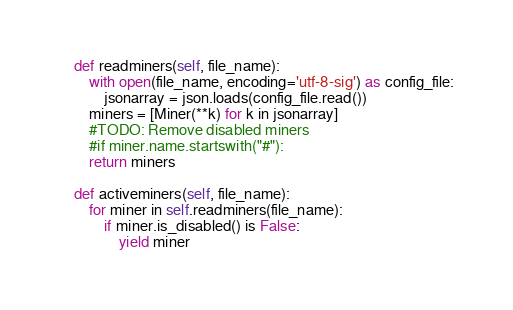<code> <loc_0><loc_0><loc_500><loc_500><_Python_>
    def readminers(self, file_name):
        with open(file_name, encoding='utf-8-sig') as config_file:
            jsonarray = json.loads(config_file.read())
        miners = [Miner(**k) for k in jsonarray]
        #TODO: Remove disabled miners
        #if miner.name.startswith("#"):
        return miners

    def activeminers(self, file_name):
        for miner in self.readminers(file_name):
            if miner.is_disabled() is False:
                yield miner
</code> 